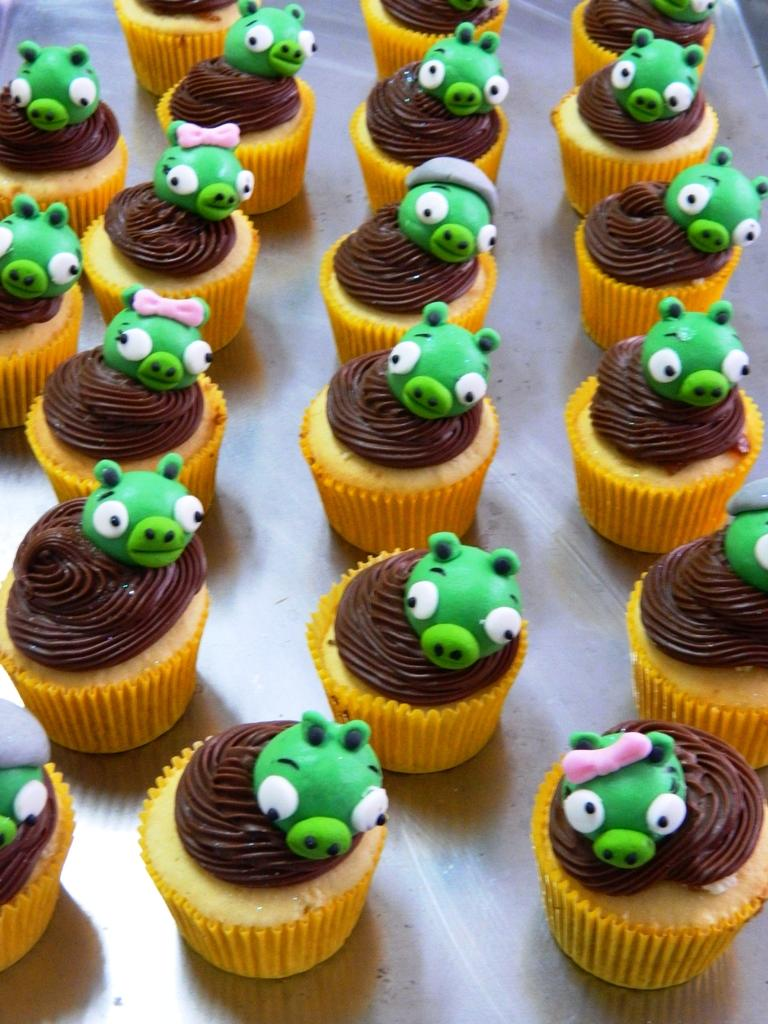What type of dessert can be seen in the image? There are cupcakes in the image. What colors are the cupcakes? The cupcakes are brown and orange in color. What feature do the cupcakes have? Each cupcake has a cartoon face. What color are the cartoon faces on the cupcakes? The cartoon faces are green in color. What type of stone is present in the image? There is no stone present in the image; it features cupcakes with cartoon faces. What day of the week is depicted in the image? The image does not depict a specific day of the week; it features cupcakes with cartoon faces. 